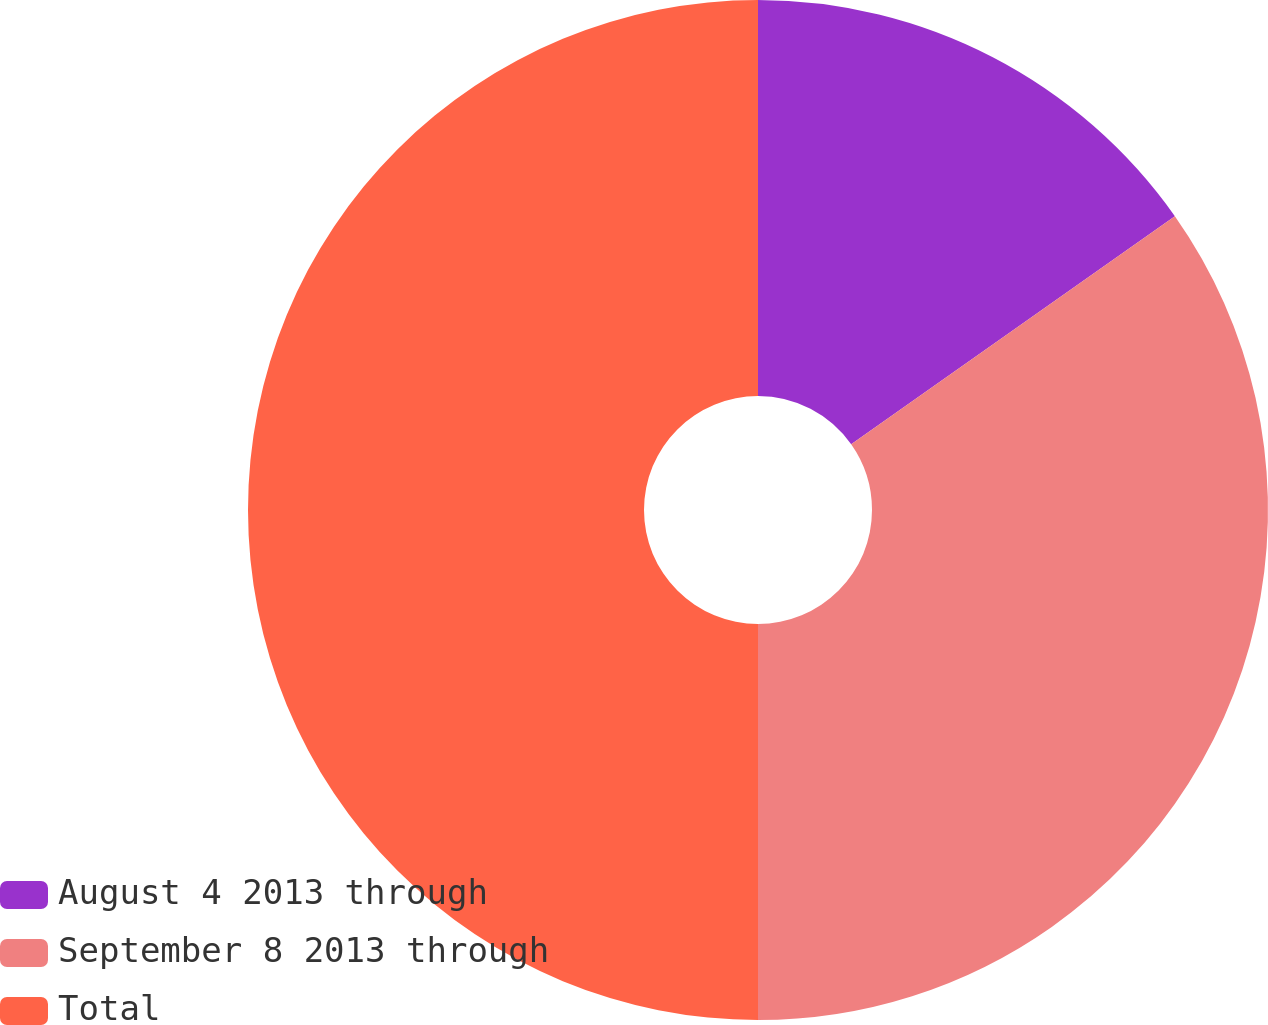<chart> <loc_0><loc_0><loc_500><loc_500><pie_chart><fcel>August 4 2013 through<fcel>September 8 2013 through<fcel>Total<nl><fcel>15.23%<fcel>34.77%<fcel>50.0%<nl></chart> 